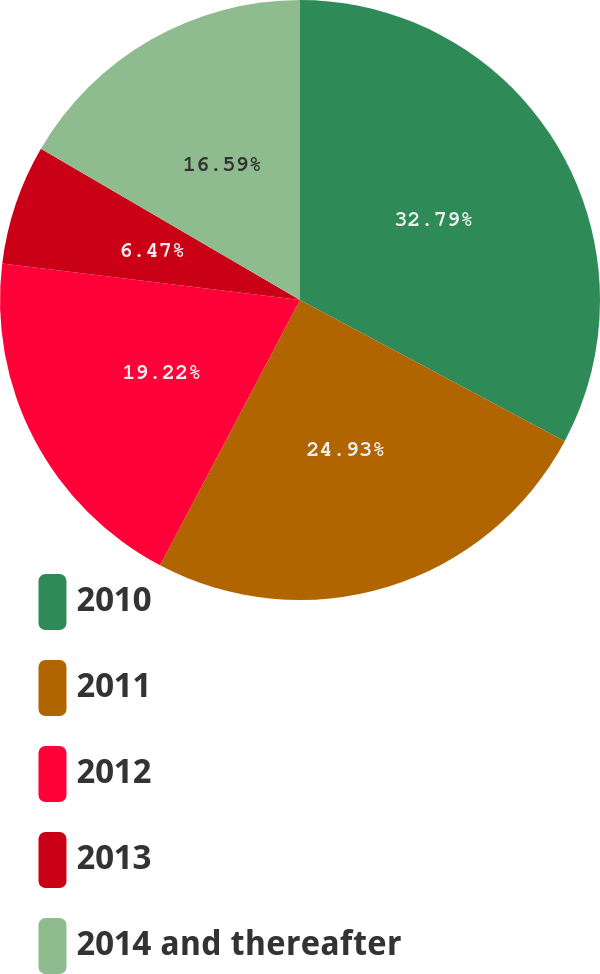<chart> <loc_0><loc_0><loc_500><loc_500><pie_chart><fcel>2010<fcel>2011<fcel>2012<fcel>2013<fcel>2014 and thereafter<nl><fcel>32.8%<fcel>24.93%<fcel>19.22%<fcel>6.47%<fcel>16.59%<nl></chart> 